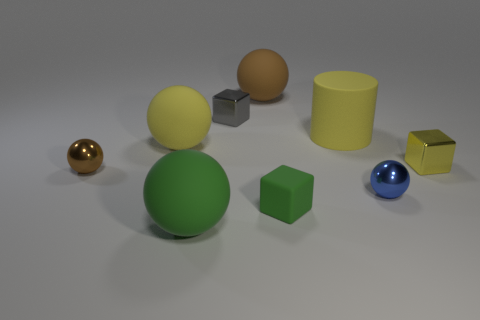There is a small cube that is behind the matte cylinder; what material is it?
Give a very brief answer. Metal. There is a green ball that is made of the same material as the big brown thing; what is its size?
Provide a short and direct response. Large. There is a big yellow ball; are there any yellow things behind it?
Provide a short and direct response. Yes. What is the size of the other brown shiny object that is the same shape as the large brown object?
Keep it short and to the point. Small. Does the cylinder have the same color as the large sphere that is on the right side of the tiny gray thing?
Make the answer very short. No. Is the cylinder the same color as the small matte cube?
Your answer should be compact. No. Is the number of yellow rubber things less than the number of tiny gray matte balls?
Keep it short and to the point. No. How many other objects are the same color as the tiny rubber block?
Make the answer very short. 1. How many large red metal objects are there?
Give a very brief answer. 0. Is the number of blue balls to the left of the brown matte object less than the number of small brown balls?
Keep it short and to the point. Yes. 